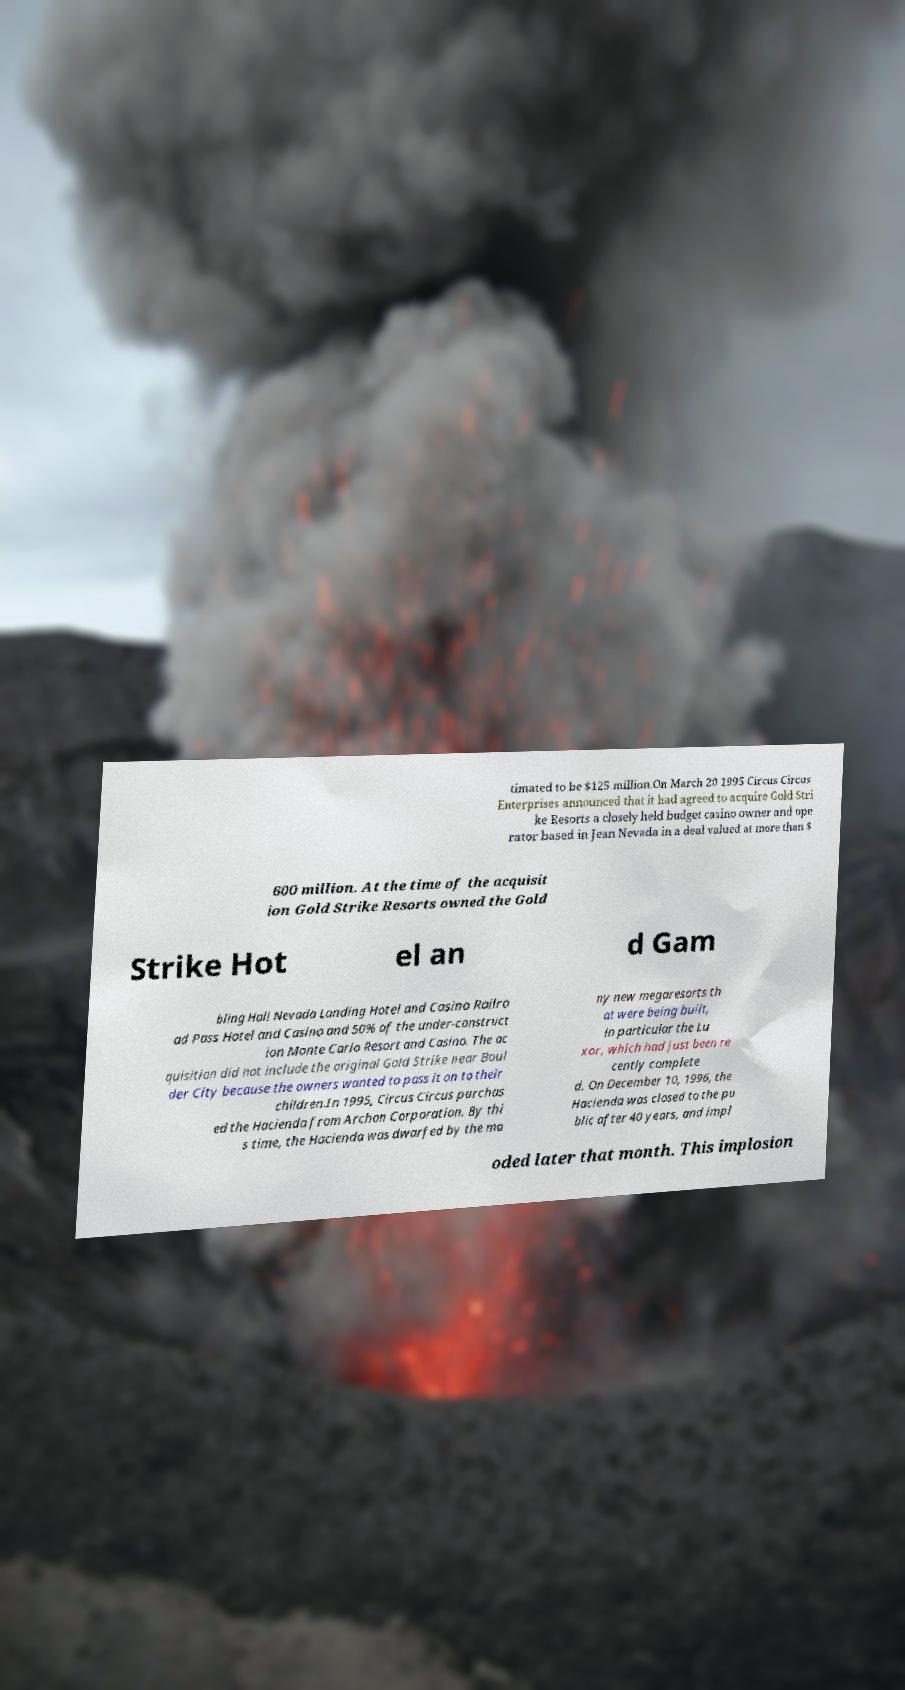Could you assist in decoding the text presented in this image and type it out clearly? timated to be $125 million.On March 20 1995 Circus Circus Enterprises announced that it had agreed to acquire Gold Stri ke Resorts a closely held budget casino owner and ope rator based in Jean Nevada in a deal valued at more than $ 600 million. At the time of the acquisit ion Gold Strike Resorts owned the Gold Strike Hot el an d Gam bling Hall Nevada Landing Hotel and Casino Railro ad Pass Hotel and Casino and 50% of the under-construct ion Monte Carlo Resort and Casino. The ac quisition did not include the original Gold Strike near Boul der City because the owners wanted to pass it on to their children.In 1995, Circus Circus purchas ed the Hacienda from Archon Corporation. By thi s time, the Hacienda was dwarfed by the ma ny new megaresorts th at were being built, in particular the Lu xor, which had just been re cently complete d. On December 10, 1996, the Hacienda was closed to the pu blic after 40 years, and impl oded later that month. This implosion 